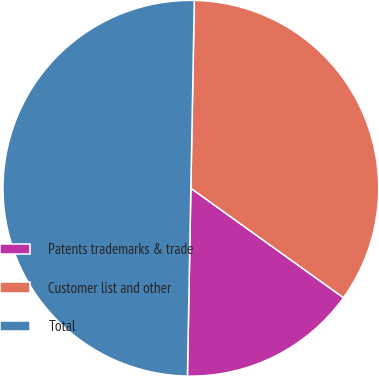Convert chart to OTSL. <chart><loc_0><loc_0><loc_500><loc_500><pie_chart><fcel>Patents trademarks & trade<fcel>Customer list and other<fcel>Total<nl><fcel>15.39%<fcel>34.61%<fcel>50.0%<nl></chart> 